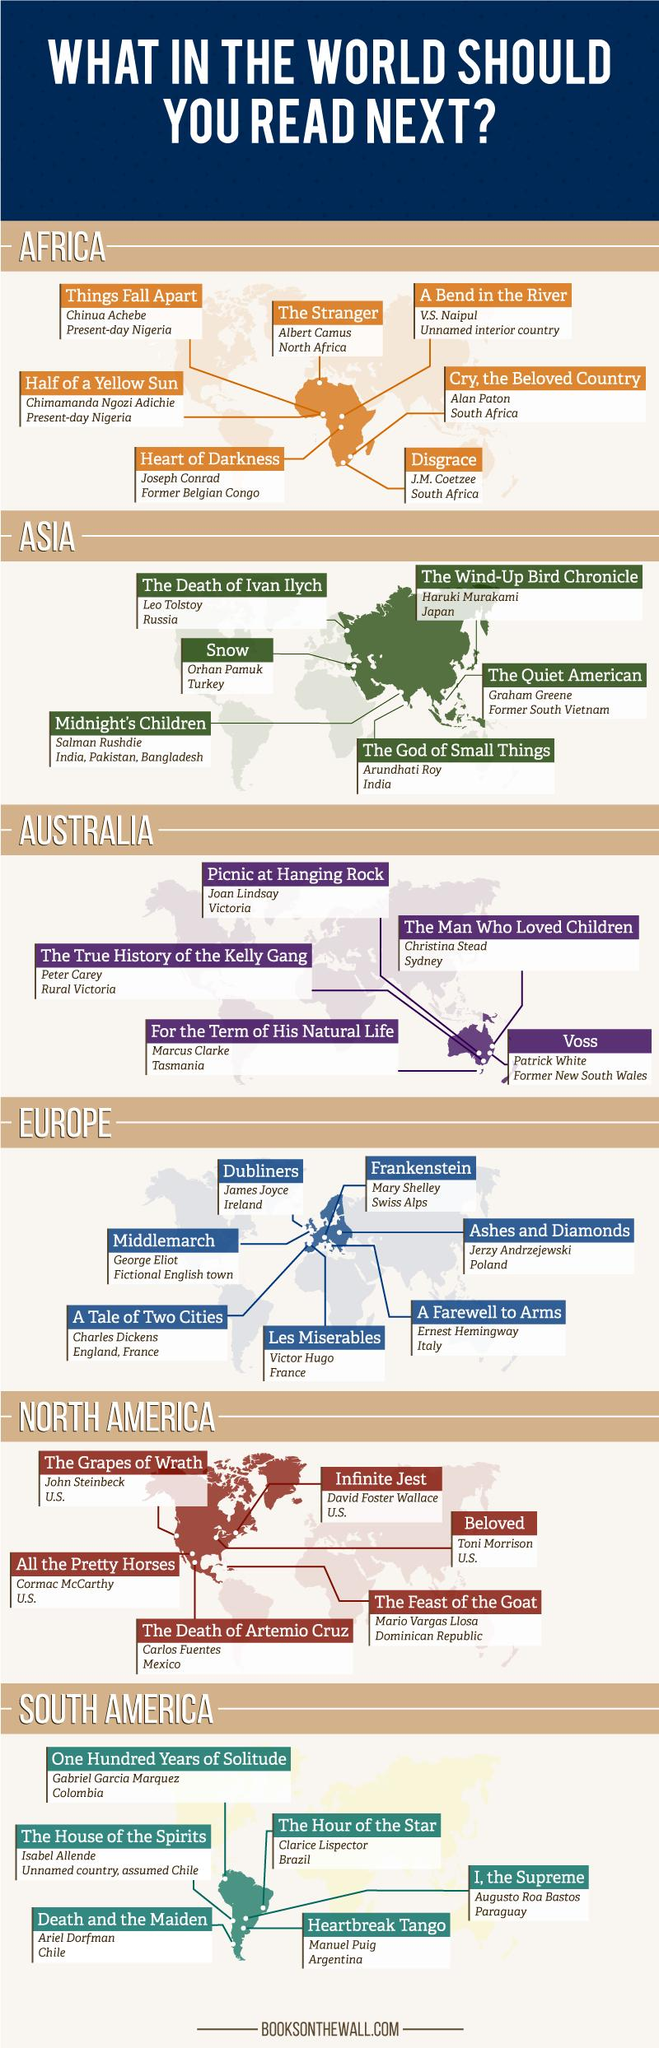Outline some significant characteristics in this image. Toni Morrison's book "Beloved" is widely acclaimed for its literary merit and deeply moving story. It is a Pulitzer Prize-winning novel that explores the complex and painful legacy of slavery in the United States. The book is known for its haunting imagery and powerful portrayal of the psychological and emotional toll that slavery had on the African American community. Arundhati Roy, the author of the book titled "The God of Small Things," wrote it. The book titled "Midnight's Children" was written by Salman Rushdie. Christina Stead, the renowned writer from Australia, is known for her remarkable contributions to literature. 